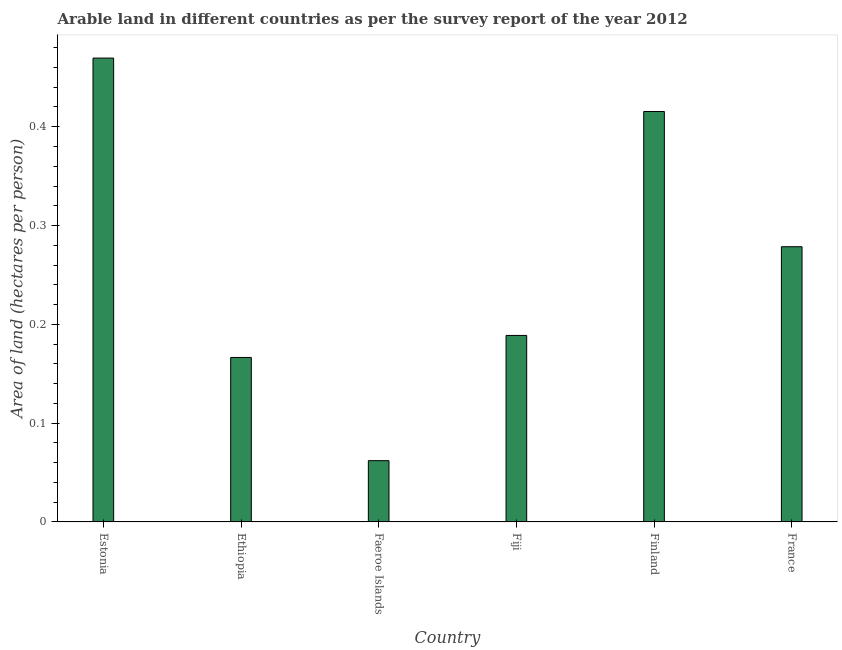Does the graph contain any zero values?
Offer a very short reply. No. Does the graph contain grids?
Provide a short and direct response. No. What is the title of the graph?
Keep it short and to the point. Arable land in different countries as per the survey report of the year 2012. What is the label or title of the X-axis?
Make the answer very short. Country. What is the label or title of the Y-axis?
Keep it short and to the point. Area of land (hectares per person). What is the area of arable land in Fiji?
Give a very brief answer. 0.19. Across all countries, what is the maximum area of arable land?
Make the answer very short. 0.47. Across all countries, what is the minimum area of arable land?
Provide a succinct answer. 0.06. In which country was the area of arable land maximum?
Ensure brevity in your answer.  Estonia. In which country was the area of arable land minimum?
Provide a short and direct response. Faeroe Islands. What is the sum of the area of arable land?
Provide a succinct answer. 1.58. What is the difference between the area of arable land in Ethiopia and Faeroe Islands?
Your answer should be very brief. 0.1. What is the average area of arable land per country?
Give a very brief answer. 0.26. What is the median area of arable land?
Make the answer very short. 0.23. What is the ratio of the area of arable land in Estonia to that in Fiji?
Offer a very short reply. 2.49. Is the area of arable land in Ethiopia less than that in France?
Provide a short and direct response. Yes. What is the difference between the highest and the second highest area of arable land?
Offer a very short reply. 0.05. What is the difference between the highest and the lowest area of arable land?
Provide a short and direct response. 0.41. In how many countries, is the area of arable land greater than the average area of arable land taken over all countries?
Keep it short and to the point. 3. Are all the bars in the graph horizontal?
Your answer should be very brief. No. How many countries are there in the graph?
Make the answer very short. 6. Are the values on the major ticks of Y-axis written in scientific E-notation?
Your answer should be compact. No. What is the Area of land (hectares per person) of Estonia?
Offer a very short reply. 0.47. What is the Area of land (hectares per person) in Ethiopia?
Offer a terse response. 0.17. What is the Area of land (hectares per person) of Faeroe Islands?
Keep it short and to the point. 0.06. What is the Area of land (hectares per person) of Fiji?
Provide a short and direct response. 0.19. What is the Area of land (hectares per person) in Finland?
Give a very brief answer. 0.42. What is the Area of land (hectares per person) in France?
Provide a short and direct response. 0.28. What is the difference between the Area of land (hectares per person) in Estonia and Ethiopia?
Your answer should be compact. 0.3. What is the difference between the Area of land (hectares per person) in Estonia and Faeroe Islands?
Your response must be concise. 0.41. What is the difference between the Area of land (hectares per person) in Estonia and Fiji?
Offer a terse response. 0.28. What is the difference between the Area of land (hectares per person) in Estonia and Finland?
Your answer should be very brief. 0.05. What is the difference between the Area of land (hectares per person) in Estonia and France?
Your answer should be compact. 0.19. What is the difference between the Area of land (hectares per person) in Ethiopia and Faeroe Islands?
Provide a short and direct response. 0.1. What is the difference between the Area of land (hectares per person) in Ethiopia and Fiji?
Give a very brief answer. -0.02. What is the difference between the Area of land (hectares per person) in Ethiopia and Finland?
Your response must be concise. -0.25. What is the difference between the Area of land (hectares per person) in Ethiopia and France?
Your answer should be very brief. -0.11. What is the difference between the Area of land (hectares per person) in Faeroe Islands and Fiji?
Give a very brief answer. -0.13. What is the difference between the Area of land (hectares per person) in Faeroe Islands and Finland?
Provide a short and direct response. -0.35. What is the difference between the Area of land (hectares per person) in Faeroe Islands and France?
Keep it short and to the point. -0.22. What is the difference between the Area of land (hectares per person) in Fiji and Finland?
Make the answer very short. -0.23. What is the difference between the Area of land (hectares per person) in Fiji and France?
Your answer should be compact. -0.09. What is the difference between the Area of land (hectares per person) in Finland and France?
Make the answer very short. 0.14. What is the ratio of the Area of land (hectares per person) in Estonia to that in Ethiopia?
Your answer should be compact. 2.82. What is the ratio of the Area of land (hectares per person) in Estonia to that in Faeroe Islands?
Your answer should be compact. 7.57. What is the ratio of the Area of land (hectares per person) in Estonia to that in Fiji?
Ensure brevity in your answer.  2.49. What is the ratio of the Area of land (hectares per person) in Estonia to that in Finland?
Your answer should be very brief. 1.13. What is the ratio of the Area of land (hectares per person) in Estonia to that in France?
Your answer should be compact. 1.69. What is the ratio of the Area of land (hectares per person) in Ethiopia to that in Faeroe Islands?
Give a very brief answer. 2.69. What is the ratio of the Area of land (hectares per person) in Ethiopia to that in Fiji?
Provide a short and direct response. 0.88. What is the ratio of the Area of land (hectares per person) in Ethiopia to that in Finland?
Provide a short and direct response. 0.4. What is the ratio of the Area of land (hectares per person) in Ethiopia to that in France?
Your answer should be compact. 0.6. What is the ratio of the Area of land (hectares per person) in Faeroe Islands to that in Fiji?
Your response must be concise. 0.33. What is the ratio of the Area of land (hectares per person) in Faeroe Islands to that in Finland?
Offer a terse response. 0.15. What is the ratio of the Area of land (hectares per person) in Faeroe Islands to that in France?
Provide a succinct answer. 0.22. What is the ratio of the Area of land (hectares per person) in Fiji to that in Finland?
Keep it short and to the point. 0.45. What is the ratio of the Area of land (hectares per person) in Fiji to that in France?
Your answer should be very brief. 0.68. What is the ratio of the Area of land (hectares per person) in Finland to that in France?
Provide a succinct answer. 1.49. 